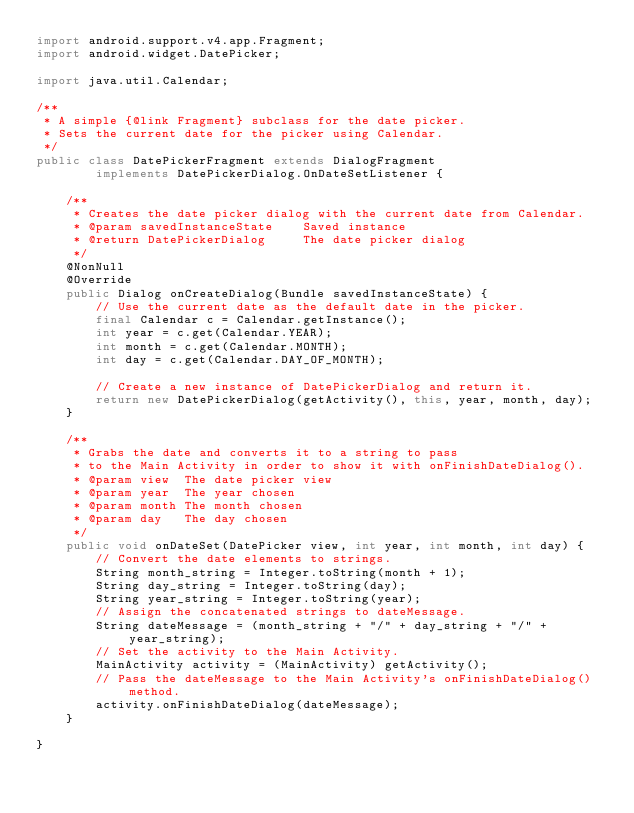<code> <loc_0><loc_0><loc_500><loc_500><_Java_>import android.support.v4.app.Fragment;
import android.widget.DatePicker;

import java.util.Calendar;

/**
 * A simple {@link Fragment} subclass for the date picker.
 * Sets the current date for the picker using Calendar.
 */
public class DatePickerFragment extends DialogFragment
        implements DatePickerDialog.OnDateSetListener {

    /**
     * Creates the date picker dialog with the current date from Calendar.
     * @param savedInstanceState    Saved instance
     * @return DatePickerDialog     The date picker dialog
     */
    @NonNull
    @Override
    public Dialog onCreateDialog(Bundle savedInstanceState) {
        // Use the current date as the default date in the picker.
        final Calendar c = Calendar.getInstance();
        int year = c.get(Calendar.YEAR);
        int month = c.get(Calendar.MONTH);
        int day = c.get(Calendar.DAY_OF_MONTH);

        // Create a new instance of DatePickerDialog and return it.
        return new DatePickerDialog(getActivity(), this, year, month, day);
    }

    /**
     * Grabs the date and converts it to a string to pass
     * to the Main Activity in order to show it with onFinishDateDialog().
     * @param view  The date picker view
     * @param year  The year chosen
     * @param month The month chosen
     * @param day   The day chosen
     */
    public void onDateSet(DatePicker view, int year, int month, int day) {
        // Convert the date elements to strings.
        String month_string = Integer.toString(month + 1);
        String day_string = Integer.toString(day);
        String year_string = Integer.toString(year);
        // Assign the concatenated strings to dateMessage.
        String dateMessage = (month_string + "/" + day_string + "/" + year_string);
        // Set the activity to the Main Activity.
        MainActivity activity = (MainActivity) getActivity();
        // Pass the dateMessage to the Main Activity's onFinishDateDialog() method.
        activity.onFinishDateDialog(dateMessage);
    }

}
</code> 